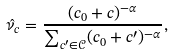<formula> <loc_0><loc_0><loc_500><loc_500>\hat { \nu } _ { c } = \frac { ( c _ { 0 } + c ) ^ { - \alpha } } { \sum _ { c ^ { \prime } \in \mathcal { C } } ( c _ { 0 } + c ^ { \prime } ) ^ { - \alpha } } ,</formula> 